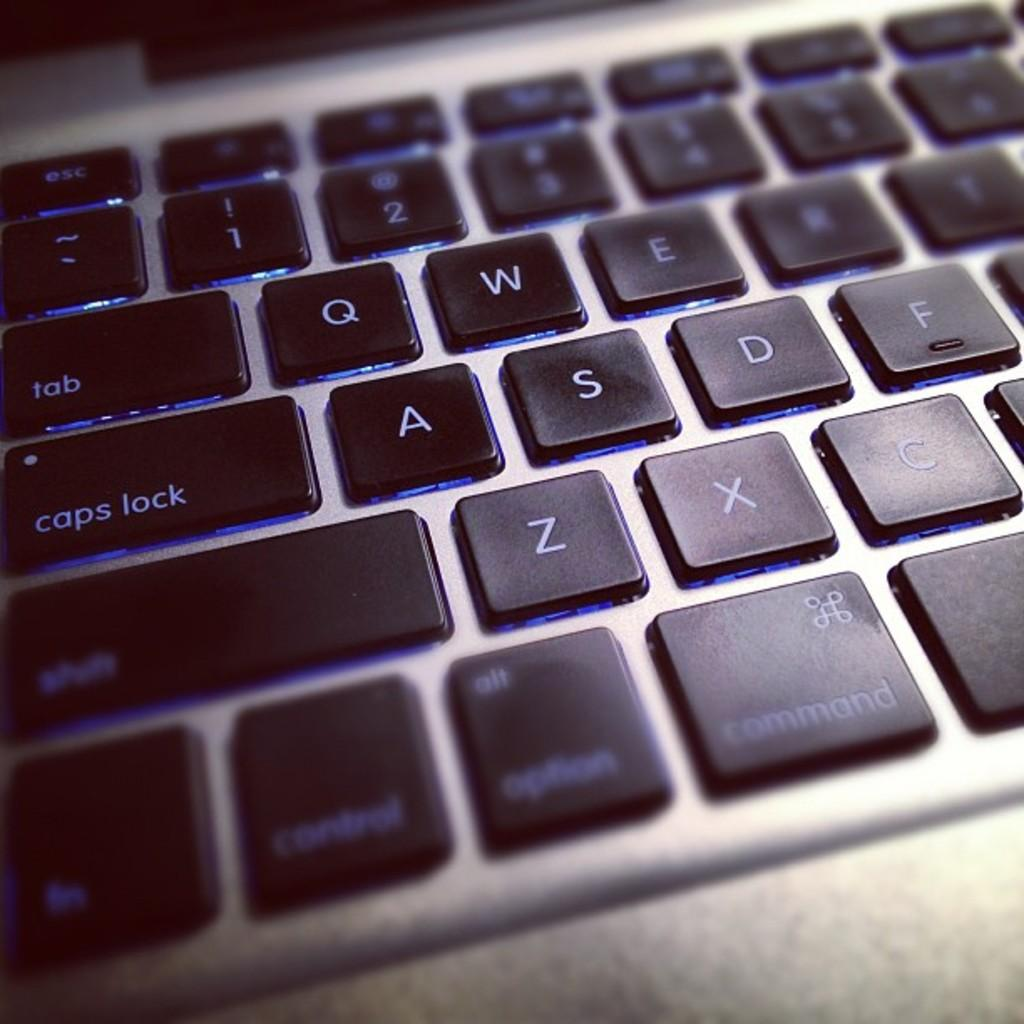<image>
Describe the image concisely. A MacBook keyboard includes a button for caps lock, and another for tab. 